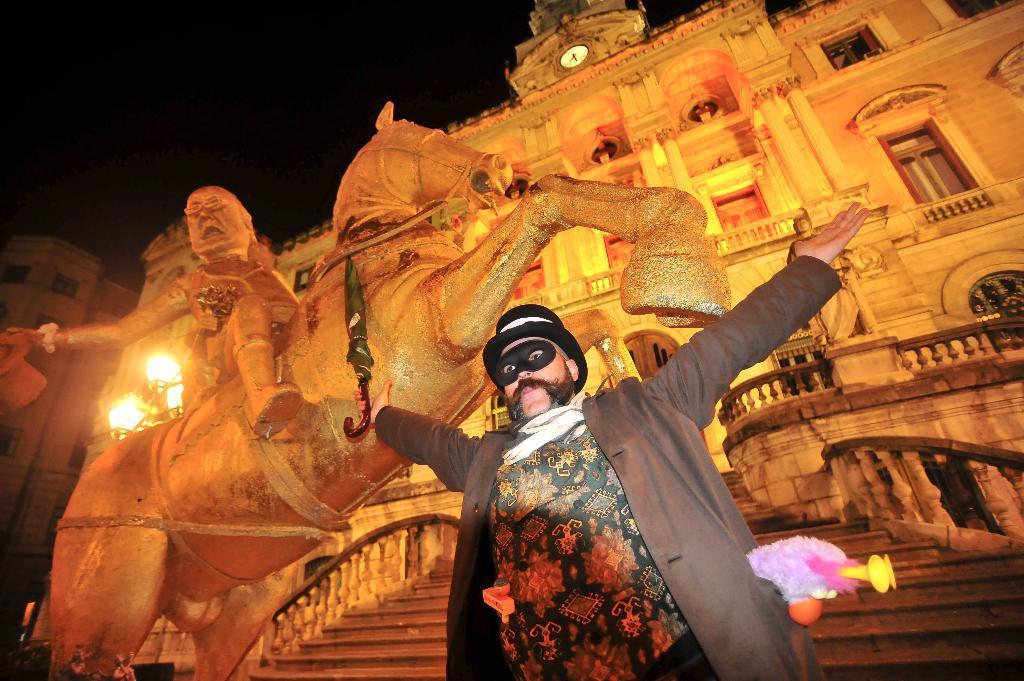Describe this image in one or two sentences. In this image I can see a person wearing dress and a jacket, black colored hat and black colored mask is standing and holding an umbrella which is black in color in his hand. In the background I can see a statue of a person sitting on the horse, few stairs, the building, a clock on the top of the building and the dark sky and I can see few lights and few other buildings in the background. 